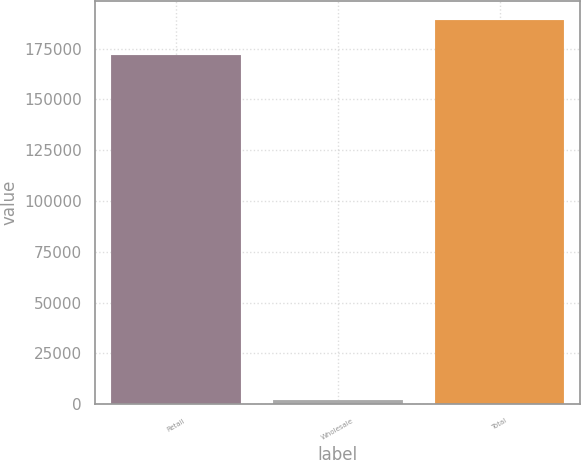Convert chart to OTSL. <chart><loc_0><loc_0><loc_500><loc_500><bar_chart><fcel>Retail<fcel>Wholesale<fcel>Total<nl><fcel>171779<fcel>2030<fcel>188957<nl></chart> 